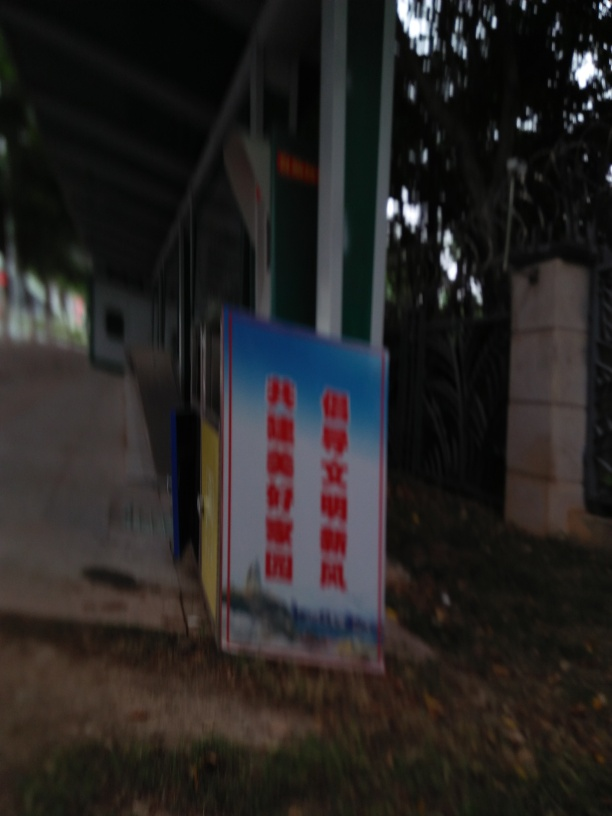What issues does this image have?
A. Blurry, focusing issues, noise, dark, text hard to read
B. Sharp, clear, noise-free, bright, legible text
C. High-resolution, well-focused, noise-free, well-lit, clear text
D. Colorful, well-focused, low noise, well-lit, readable text
Answer with the option's letter from the given choices directly.
 A. 